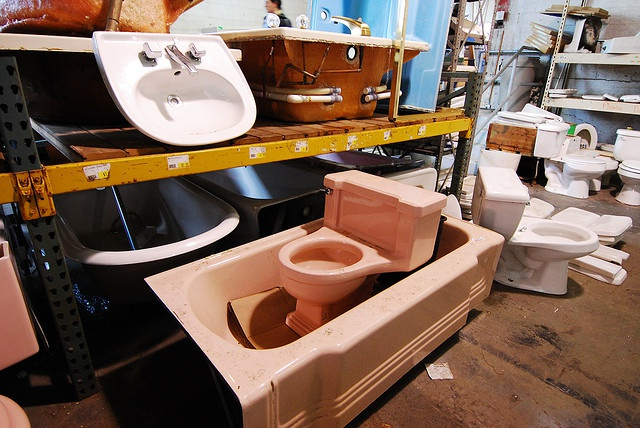Describe the objects in this image and their specific colors. I can see toilet in pink, brown, and tan tones, sink in pink, white, darkgray, and lightgray tones, sink in pink, black, lightgray, and orange tones, toilet in pink, lightgray, gray, and darkgray tones, and toilet in pink, lightgray, darkgray, and gray tones in this image. 